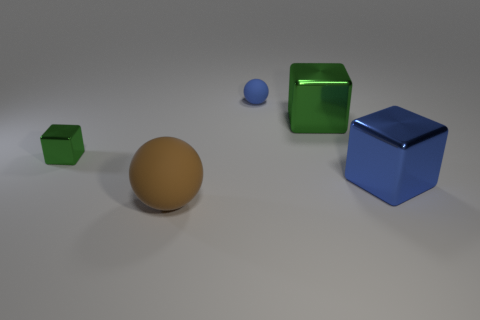Add 3 large brown balls. How many objects exist? 8 Subtract all spheres. How many objects are left? 3 Subtract all big objects. Subtract all big blue objects. How many objects are left? 1 Add 1 tiny metallic cubes. How many tiny metallic cubes are left? 2 Add 5 big blue metallic cubes. How many big blue metallic cubes exist? 6 Subtract 0 gray spheres. How many objects are left? 5 